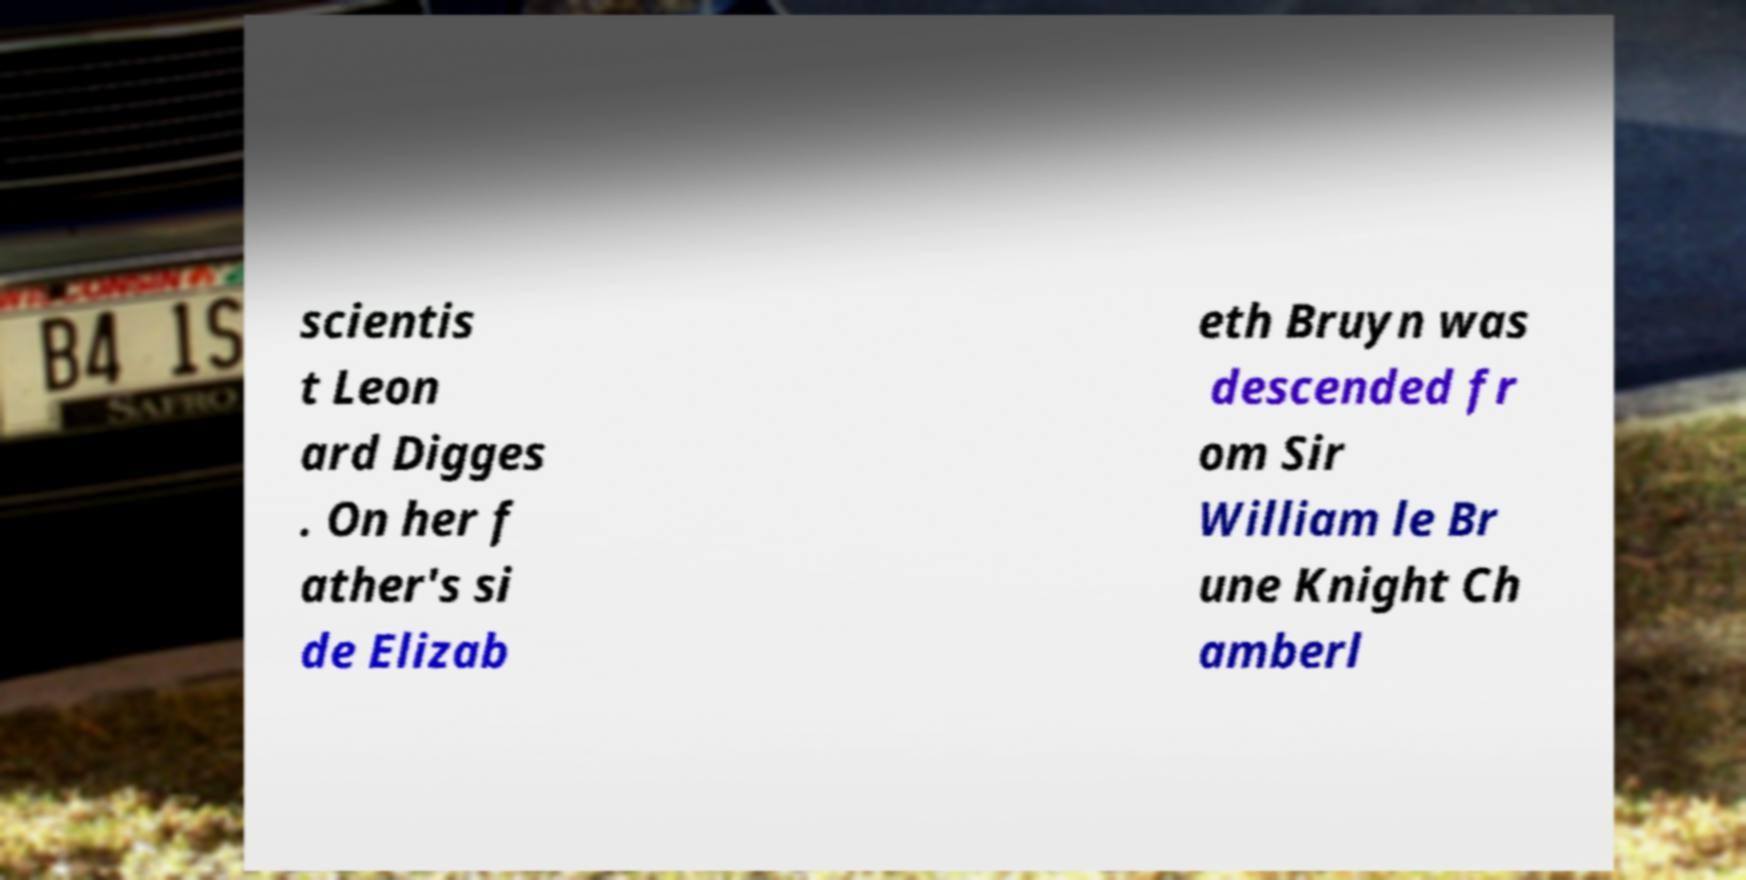Can you accurately transcribe the text from the provided image for me? scientis t Leon ard Digges . On her f ather's si de Elizab eth Bruyn was descended fr om Sir William le Br une Knight Ch amberl 